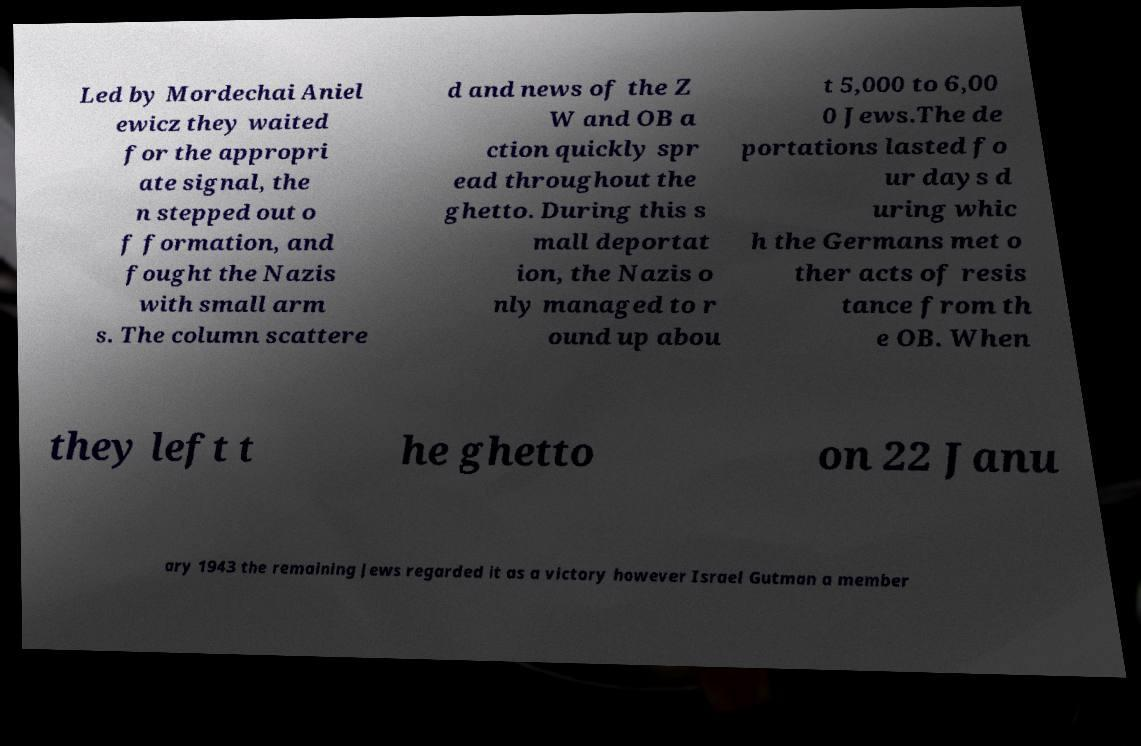Please identify and transcribe the text found in this image. Led by Mordechai Aniel ewicz they waited for the appropri ate signal, the n stepped out o f formation, and fought the Nazis with small arm s. The column scattere d and news of the Z W and OB a ction quickly spr ead throughout the ghetto. During this s mall deportat ion, the Nazis o nly managed to r ound up abou t 5,000 to 6,00 0 Jews.The de portations lasted fo ur days d uring whic h the Germans met o ther acts of resis tance from th e OB. When they left t he ghetto on 22 Janu ary 1943 the remaining Jews regarded it as a victory however Israel Gutman a member 